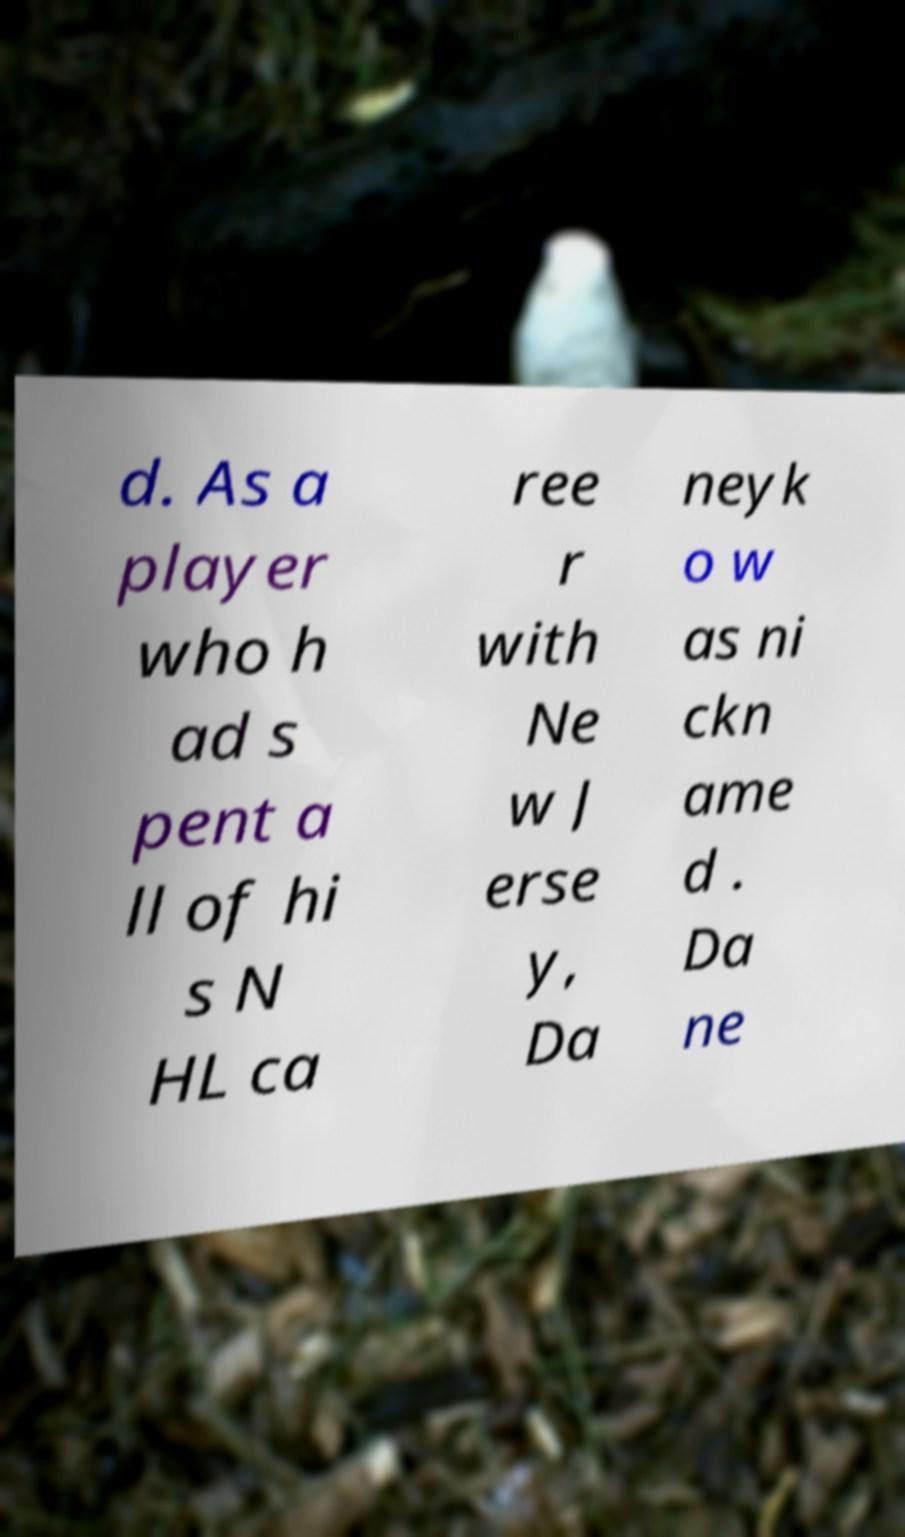For documentation purposes, I need the text within this image transcribed. Could you provide that? d. As a player who h ad s pent a ll of hi s N HL ca ree r with Ne w J erse y, Da neyk o w as ni ckn ame d . Da ne 